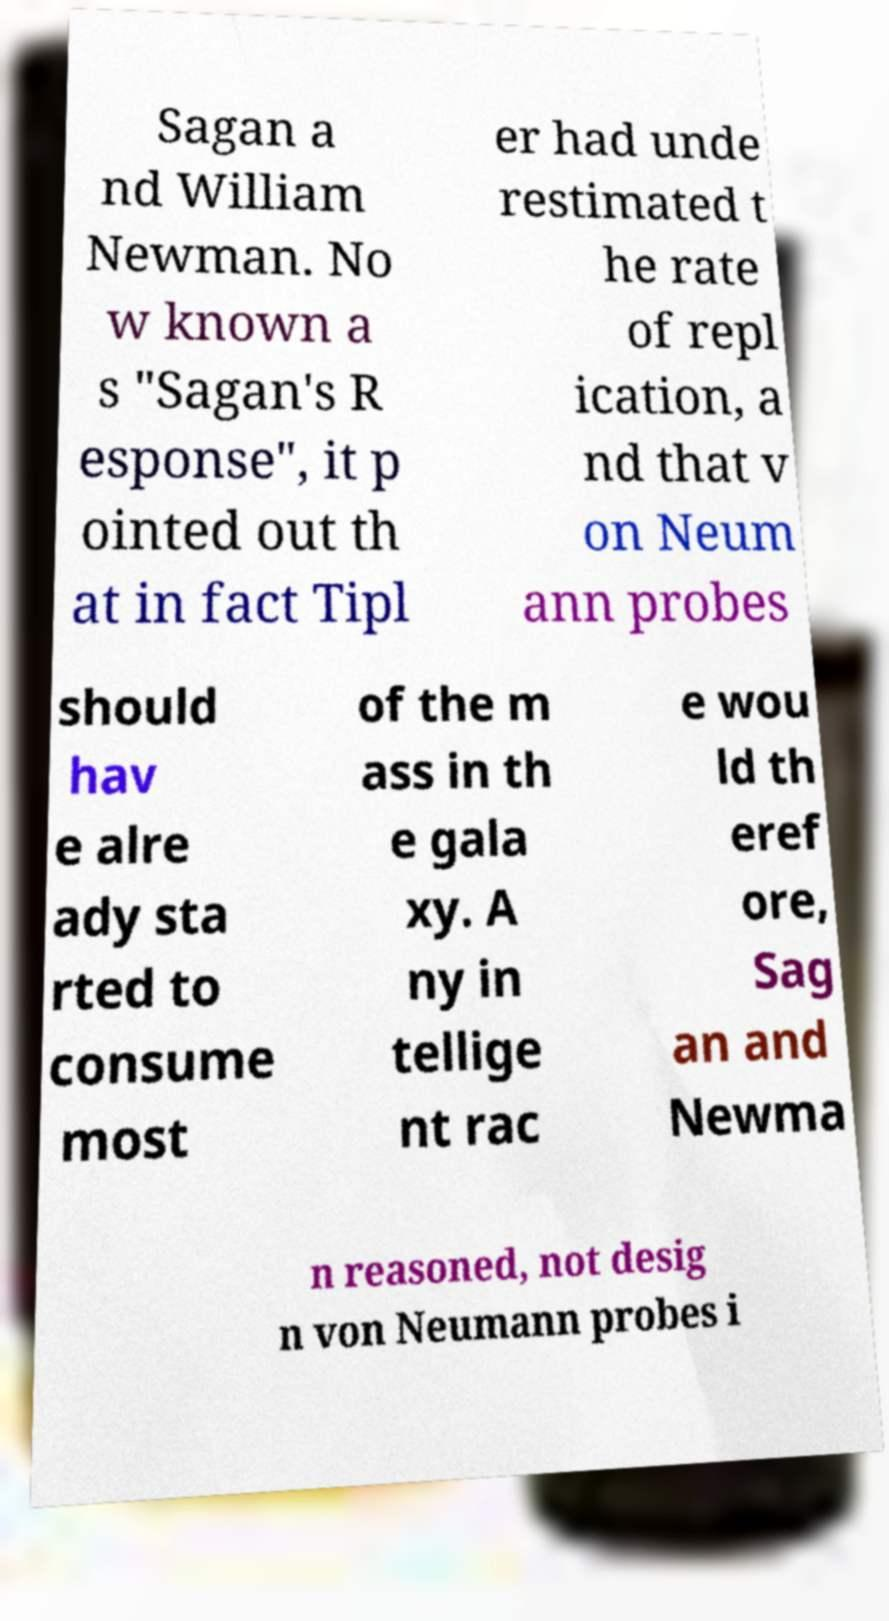Please identify and transcribe the text found in this image. Sagan a nd William Newman. No w known a s "Sagan's R esponse", it p ointed out th at in fact Tipl er had unde restimated t he rate of repl ication, a nd that v on Neum ann probes should hav e alre ady sta rted to consume most of the m ass in th e gala xy. A ny in tellige nt rac e wou ld th eref ore, Sag an and Newma n reasoned, not desig n von Neumann probes i 